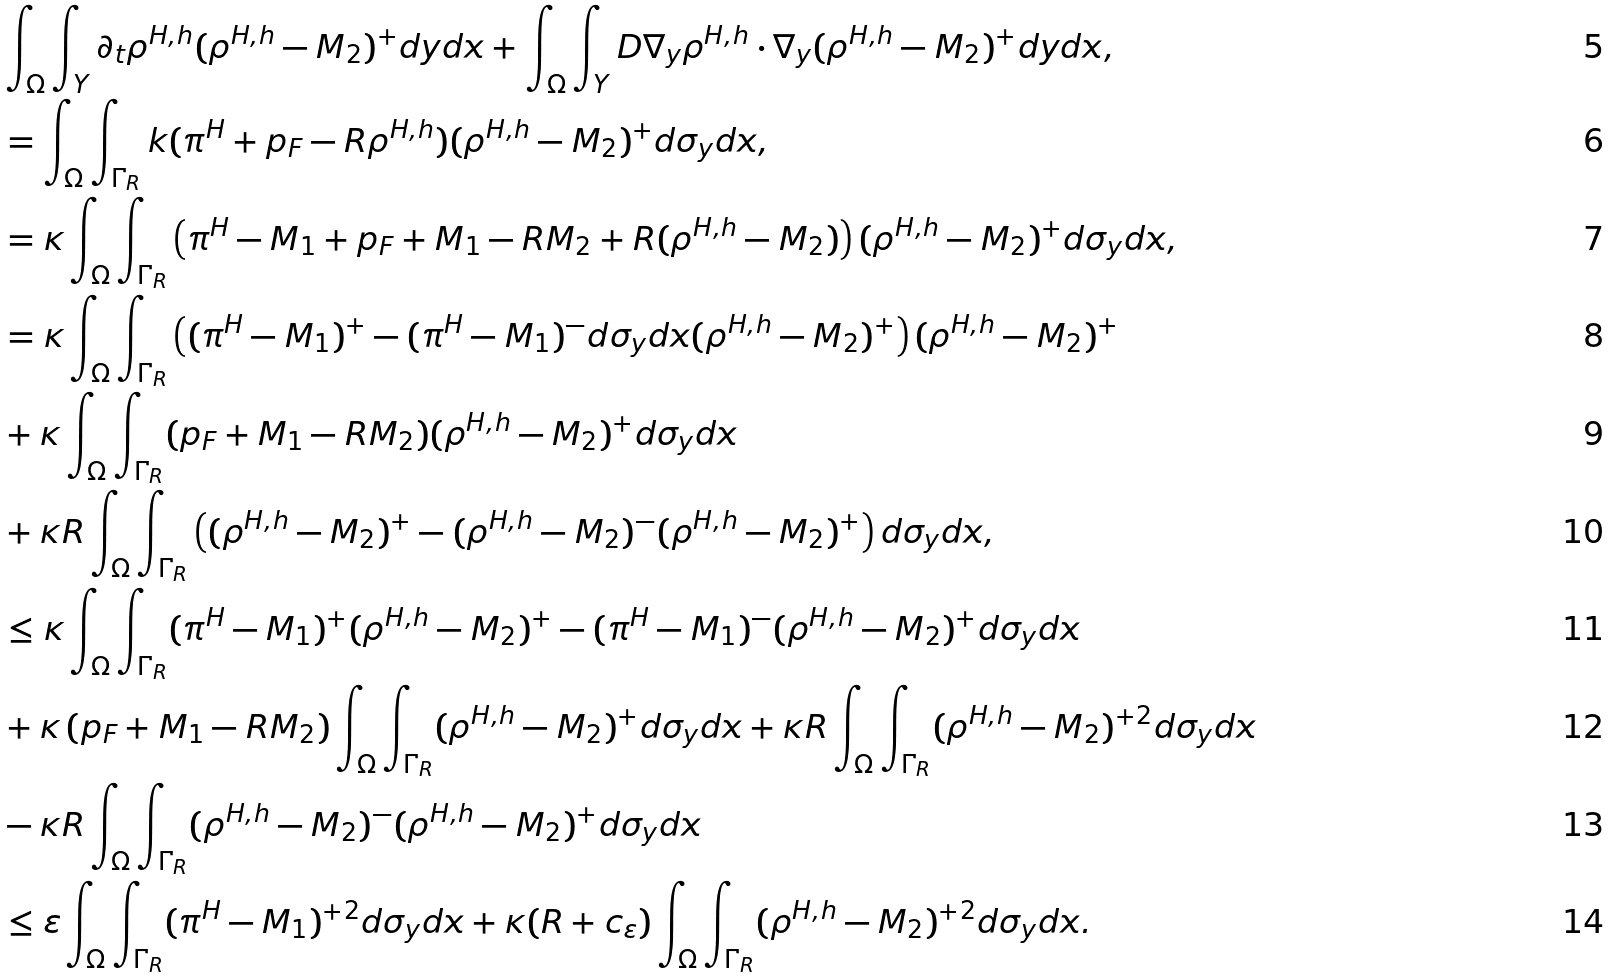<formula> <loc_0><loc_0><loc_500><loc_500>& \int _ { \Omega } \int _ { Y } \partial _ { t } \rho ^ { H , h } ( \rho ^ { H , h } - M _ { 2 } ) ^ { + } d y d x + \int _ { \Omega } \int _ { Y } D \nabla _ { y } \rho ^ { H , h } \cdot \nabla _ { y } ( \rho ^ { H , h } - M _ { 2 } ) ^ { + } d y d x , \\ & = \int _ { \Omega } \int _ { \Gamma _ { R } } k ( \pi ^ { H } + p _ { F } - R \rho ^ { H , h } ) ( \rho ^ { H , h } - M _ { 2 } ) ^ { + } d \sigma _ { y } d x , \\ & = \kappa \int _ { \Omega } \int _ { \Gamma _ { R } } \left ( \pi ^ { H } - M _ { 1 } + p _ { F } + M _ { 1 } - R M _ { 2 } + R ( \rho ^ { H , h } - M _ { 2 } ) \right ) ( \rho ^ { H , h } - M _ { 2 } ) ^ { + } d \sigma _ { y } d x , \\ & = \kappa \int _ { \Omega } \int _ { \Gamma _ { R } } \left ( ( \pi ^ { H } - M _ { 1 } ) ^ { + } - ( \pi ^ { H } - M _ { 1 } ) ^ { - } d \sigma _ { y } d x ( \rho ^ { H , h } - M _ { 2 } ) ^ { + } \right ) ( \rho ^ { H , h } - M _ { 2 } ) ^ { + } \\ & + \kappa \int _ { \Omega } \int _ { \Gamma _ { R } } ( p _ { F } + M _ { 1 } - R M _ { 2 } ) ( \rho ^ { H , h } - M _ { 2 } ) ^ { + } d \sigma _ { y } d x \\ & + \kappa R \int _ { \Omega } \int _ { \Gamma _ { R } } \left ( ( \rho ^ { H , h } - M _ { 2 } ) ^ { + } - ( \rho ^ { H , h } - M _ { 2 } ) ^ { - } ( \rho ^ { H , h } - M _ { 2 } ) ^ { + } \right ) d \sigma _ { y } d x , \\ & \leq \kappa \int _ { \Omega } \int _ { \Gamma _ { R } } ( \pi ^ { H } - M _ { 1 } ) ^ { + } ( \rho ^ { H , h } - M _ { 2 } ) ^ { + } - ( \pi ^ { H } - M _ { 1 } ) ^ { - } ( \rho ^ { H , h } - M _ { 2 } ) ^ { + } d \sigma _ { y } d x \\ & + \kappa \left ( p _ { F } + M _ { 1 } - R M _ { 2 } \right ) \int _ { \Omega } \int _ { \Gamma _ { R } } ( \rho ^ { H , h } - M _ { 2 } ) ^ { + } d \sigma _ { y } d x + \kappa R \int _ { \Omega } \int _ { \Gamma _ { R } } ( \rho ^ { H , h } - M _ { 2 } ) ^ { + 2 } d \sigma _ { y } d x \\ & - \kappa R \int _ { \Omega } \int _ { \Gamma _ { R } } ( \rho ^ { H , h } - M _ { 2 } ) ^ { - } ( \rho ^ { H , h } - M _ { 2 } ) ^ { + } d \sigma _ { y } d x \\ & \leq \varepsilon \int _ { \Omega } \int _ { \Gamma _ { R } } ( \pi ^ { H } - M _ { 1 } ) ^ { + 2 } d \sigma _ { y } d x + \kappa ( R + c _ { \varepsilon } ) \int _ { \Omega } \int _ { \Gamma _ { R } } ( \rho ^ { H , h } - M _ { 2 } ) ^ { + 2 } d \sigma _ { y } d x .</formula> 